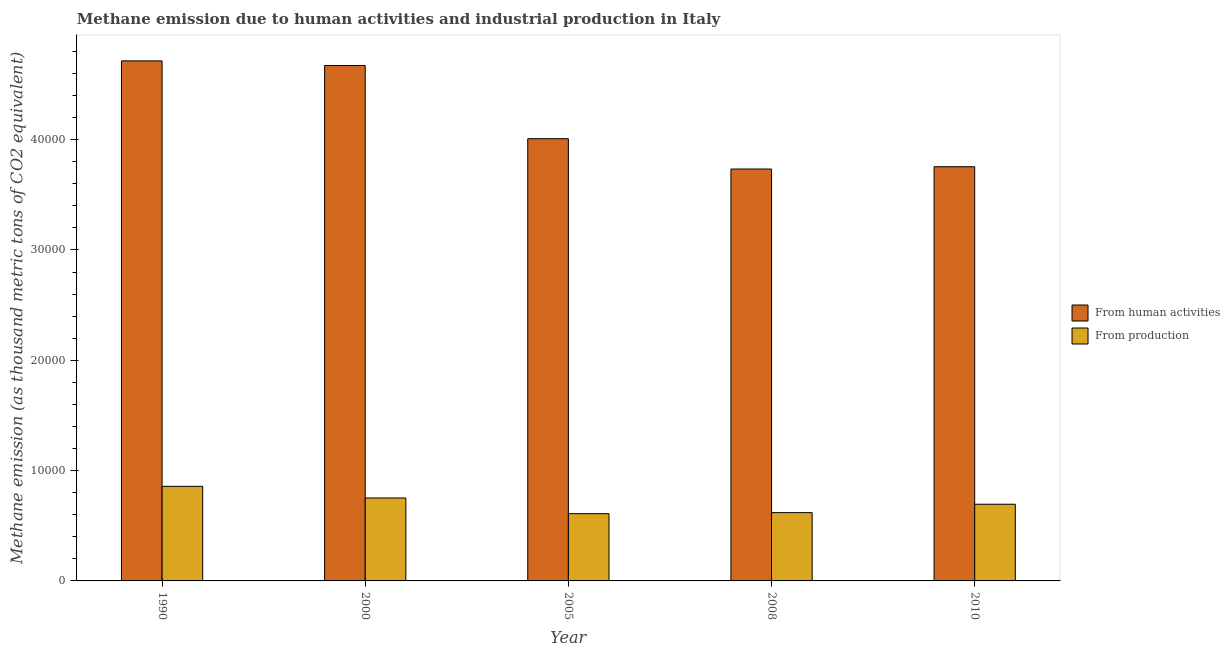How many groups of bars are there?
Your response must be concise. 5. Are the number of bars per tick equal to the number of legend labels?
Provide a short and direct response. Yes. How many bars are there on the 1st tick from the left?
Provide a short and direct response. 2. In how many cases, is the number of bars for a given year not equal to the number of legend labels?
Your response must be concise. 0. What is the amount of emissions from human activities in 2005?
Your response must be concise. 4.01e+04. Across all years, what is the maximum amount of emissions generated from industries?
Offer a very short reply. 8574.9. Across all years, what is the minimum amount of emissions from human activities?
Your answer should be compact. 3.73e+04. In which year was the amount of emissions from human activities maximum?
Provide a succinct answer. 1990. In which year was the amount of emissions from human activities minimum?
Ensure brevity in your answer.  2008. What is the total amount of emissions generated from industries in the graph?
Keep it short and to the point. 3.53e+04. What is the difference between the amount of emissions from human activities in 1990 and that in 2010?
Give a very brief answer. 9595.9. What is the difference between the amount of emissions generated from industries in 1990 and the amount of emissions from human activities in 2010?
Provide a short and direct response. 1623.4. What is the average amount of emissions generated from industries per year?
Make the answer very short. 7066.6. In the year 1990, what is the difference between the amount of emissions from human activities and amount of emissions generated from industries?
Your answer should be compact. 0. In how many years, is the amount of emissions generated from industries greater than 16000 thousand metric tons?
Ensure brevity in your answer.  0. What is the ratio of the amount of emissions from human activities in 1990 to that in 2008?
Keep it short and to the point. 1.26. What is the difference between the highest and the second highest amount of emissions generated from industries?
Offer a terse response. 1055.7. What is the difference between the highest and the lowest amount of emissions generated from industries?
Your answer should be compact. 2478. In how many years, is the amount of emissions generated from industries greater than the average amount of emissions generated from industries taken over all years?
Offer a very short reply. 2. What does the 2nd bar from the left in 2008 represents?
Give a very brief answer. From production. What does the 1st bar from the right in 2008 represents?
Keep it short and to the point. From production. What is the difference between two consecutive major ticks on the Y-axis?
Your answer should be very brief. 10000. Are the values on the major ticks of Y-axis written in scientific E-notation?
Your answer should be compact. No. Does the graph contain any zero values?
Your response must be concise. No. Does the graph contain grids?
Your answer should be compact. No. How are the legend labels stacked?
Keep it short and to the point. Vertical. What is the title of the graph?
Provide a short and direct response. Methane emission due to human activities and industrial production in Italy. What is the label or title of the X-axis?
Your response must be concise. Year. What is the label or title of the Y-axis?
Offer a terse response. Methane emission (as thousand metric tons of CO2 equivalent). What is the Methane emission (as thousand metric tons of CO2 equivalent) in From human activities in 1990?
Your answer should be compact. 4.71e+04. What is the Methane emission (as thousand metric tons of CO2 equivalent) in From production in 1990?
Your answer should be compact. 8574.9. What is the Methane emission (as thousand metric tons of CO2 equivalent) in From human activities in 2000?
Your response must be concise. 4.67e+04. What is the Methane emission (as thousand metric tons of CO2 equivalent) of From production in 2000?
Your answer should be compact. 7519.2. What is the Methane emission (as thousand metric tons of CO2 equivalent) in From human activities in 2005?
Offer a terse response. 4.01e+04. What is the Methane emission (as thousand metric tons of CO2 equivalent) of From production in 2005?
Your answer should be compact. 6096.9. What is the Methane emission (as thousand metric tons of CO2 equivalent) of From human activities in 2008?
Offer a terse response. 3.73e+04. What is the Methane emission (as thousand metric tons of CO2 equivalent) of From production in 2008?
Keep it short and to the point. 6190.5. What is the Methane emission (as thousand metric tons of CO2 equivalent) of From human activities in 2010?
Offer a terse response. 3.75e+04. What is the Methane emission (as thousand metric tons of CO2 equivalent) in From production in 2010?
Your answer should be compact. 6951.5. Across all years, what is the maximum Methane emission (as thousand metric tons of CO2 equivalent) in From human activities?
Keep it short and to the point. 4.71e+04. Across all years, what is the maximum Methane emission (as thousand metric tons of CO2 equivalent) in From production?
Make the answer very short. 8574.9. Across all years, what is the minimum Methane emission (as thousand metric tons of CO2 equivalent) in From human activities?
Keep it short and to the point. 3.73e+04. Across all years, what is the minimum Methane emission (as thousand metric tons of CO2 equivalent) in From production?
Keep it short and to the point. 6096.9. What is the total Methane emission (as thousand metric tons of CO2 equivalent) in From human activities in the graph?
Provide a short and direct response. 2.09e+05. What is the total Methane emission (as thousand metric tons of CO2 equivalent) in From production in the graph?
Give a very brief answer. 3.53e+04. What is the difference between the Methane emission (as thousand metric tons of CO2 equivalent) in From human activities in 1990 and that in 2000?
Your answer should be very brief. 418.9. What is the difference between the Methane emission (as thousand metric tons of CO2 equivalent) of From production in 1990 and that in 2000?
Ensure brevity in your answer.  1055.7. What is the difference between the Methane emission (as thousand metric tons of CO2 equivalent) in From human activities in 1990 and that in 2005?
Offer a terse response. 7054.5. What is the difference between the Methane emission (as thousand metric tons of CO2 equivalent) of From production in 1990 and that in 2005?
Offer a very short reply. 2478. What is the difference between the Methane emission (as thousand metric tons of CO2 equivalent) in From human activities in 1990 and that in 2008?
Keep it short and to the point. 9804.1. What is the difference between the Methane emission (as thousand metric tons of CO2 equivalent) in From production in 1990 and that in 2008?
Your response must be concise. 2384.4. What is the difference between the Methane emission (as thousand metric tons of CO2 equivalent) in From human activities in 1990 and that in 2010?
Your response must be concise. 9595.9. What is the difference between the Methane emission (as thousand metric tons of CO2 equivalent) of From production in 1990 and that in 2010?
Make the answer very short. 1623.4. What is the difference between the Methane emission (as thousand metric tons of CO2 equivalent) in From human activities in 2000 and that in 2005?
Your answer should be very brief. 6635.6. What is the difference between the Methane emission (as thousand metric tons of CO2 equivalent) in From production in 2000 and that in 2005?
Provide a short and direct response. 1422.3. What is the difference between the Methane emission (as thousand metric tons of CO2 equivalent) in From human activities in 2000 and that in 2008?
Your response must be concise. 9385.2. What is the difference between the Methane emission (as thousand metric tons of CO2 equivalent) of From production in 2000 and that in 2008?
Give a very brief answer. 1328.7. What is the difference between the Methane emission (as thousand metric tons of CO2 equivalent) in From human activities in 2000 and that in 2010?
Keep it short and to the point. 9177. What is the difference between the Methane emission (as thousand metric tons of CO2 equivalent) of From production in 2000 and that in 2010?
Your answer should be compact. 567.7. What is the difference between the Methane emission (as thousand metric tons of CO2 equivalent) of From human activities in 2005 and that in 2008?
Your answer should be very brief. 2749.6. What is the difference between the Methane emission (as thousand metric tons of CO2 equivalent) in From production in 2005 and that in 2008?
Offer a very short reply. -93.6. What is the difference between the Methane emission (as thousand metric tons of CO2 equivalent) in From human activities in 2005 and that in 2010?
Your answer should be compact. 2541.4. What is the difference between the Methane emission (as thousand metric tons of CO2 equivalent) in From production in 2005 and that in 2010?
Provide a short and direct response. -854.6. What is the difference between the Methane emission (as thousand metric tons of CO2 equivalent) in From human activities in 2008 and that in 2010?
Your response must be concise. -208.2. What is the difference between the Methane emission (as thousand metric tons of CO2 equivalent) of From production in 2008 and that in 2010?
Offer a very short reply. -761. What is the difference between the Methane emission (as thousand metric tons of CO2 equivalent) in From human activities in 1990 and the Methane emission (as thousand metric tons of CO2 equivalent) in From production in 2000?
Your response must be concise. 3.96e+04. What is the difference between the Methane emission (as thousand metric tons of CO2 equivalent) of From human activities in 1990 and the Methane emission (as thousand metric tons of CO2 equivalent) of From production in 2005?
Your answer should be very brief. 4.10e+04. What is the difference between the Methane emission (as thousand metric tons of CO2 equivalent) in From human activities in 1990 and the Methane emission (as thousand metric tons of CO2 equivalent) in From production in 2008?
Your answer should be compact. 4.10e+04. What is the difference between the Methane emission (as thousand metric tons of CO2 equivalent) in From human activities in 1990 and the Methane emission (as thousand metric tons of CO2 equivalent) in From production in 2010?
Offer a very short reply. 4.02e+04. What is the difference between the Methane emission (as thousand metric tons of CO2 equivalent) in From human activities in 2000 and the Methane emission (as thousand metric tons of CO2 equivalent) in From production in 2005?
Your response must be concise. 4.06e+04. What is the difference between the Methane emission (as thousand metric tons of CO2 equivalent) of From human activities in 2000 and the Methane emission (as thousand metric tons of CO2 equivalent) of From production in 2008?
Offer a terse response. 4.05e+04. What is the difference between the Methane emission (as thousand metric tons of CO2 equivalent) of From human activities in 2000 and the Methane emission (as thousand metric tons of CO2 equivalent) of From production in 2010?
Give a very brief answer. 3.98e+04. What is the difference between the Methane emission (as thousand metric tons of CO2 equivalent) of From human activities in 2005 and the Methane emission (as thousand metric tons of CO2 equivalent) of From production in 2008?
Your answer should be compact. 3.39e+04. What is the difference between the Methane emission (as thousand metric tons of CO2 equivalent) in From human activities in 2005 and the Methane emission (as thousand metric tons of CO2 equivalent) in From production in 2010?
Offer a terse response. 3.31e+04. What is the difference between the Methane emission (as thousand metric tons of CO2 equivalent) in From human activities in 2008 and the Methane emission (as thousand metric tons of CO2 equivalent) in From production in 2010?
Give a very brief answer. 3.04e+04. What is the average Methane emission (as thousand metric tons of CO2 equivalent) of From human activities per year?
Offer a terse response. 4.18e+04. What is the average Methane emission (as thousand metric tons of CO2 equivalent) in From production per year?
Make the answer very short. 7066.6. In the year 1990, what is the difference between the Methane emission (as thousand metric tons of CO2 equivalent) in From human activities and Methane emission (as thousand metric tons of CO2 equivalent) in From production?
Give a very brief answer. 3.86e+04. In the year 2000, what is the difference between the Methane emission (as thousand metric tons of CO2 equivalent) of From human activities and Methane emission (as thousand metric tons of CO2 equivalent) of From production?
Keep it short and to the point. 3.92e+04. In the year 2005, what is the difference between the Methane emission (as thousand metric tons of CO2 equivalent) in From human activities and Methane emission (as thousand metric tons of CO2 equivalent) in From production?
Offer a terse response. 3.40e+04. In the year 2008, what is the difference between the Methane emission (as thousand metric tons of CO2 equivalent) of From human activities and Methane emission (as thousand metric tons of CO2 equivalent) of From production?
Provide a succinct answer. 3.11e+04. In the year 2010, what is the difference between the Methane emission (as thousand metric tons of CO2 equivalent) in From human activities and Methane emission (as thousand metric tons of CO2 equivalent) in From production?
Your response must be concise. 3.06e+04. What is the ratio of the Methane emission (as thousand metric tons of CO2 equivalent) in From human activities in 1990 to that in 2000?
Provide a succinct answer. 1.01. What is the ratio of the Methane emission (as thousand metric tons of CO2 equivalent) of From production in 1990 to that in 2000?
Your response must be concise. 1.14. What is the ratio of the Methane emission (as thousand metric tons of CO2 equivalent) in From human activities in 1990 to that in 2005?
Offer a very short reply. 1.18. What is the ratio of the Methane emission (as thousand metric tons of CO2 equivalent) of From production in 1990 to that in 2005?
Offer a terse response. 1.41. What is the ratio of the Methane emission (as thousand metric tons of CO2 equivalent) in From human activities in 1990 to that in 2008?
Your answer should be very brief. 1.26. What is the ratio of the Methane emission (as thousand metric tons of CO2 equivalent) of From production in 1990 to that in 2008?
Make the answer very short. 1.39. What is the ratio of the Methane emission (as thousand metric tons of CO2 equivalent) of From human activities in 1990 to that in 2010?
Offer a very short reply. 1.26. What is the ratio of the Methane emission (as thousand metric tons of CO2 equivalent) of From production in 1990 to that in 2010?
Give a very brief answer. 1.23. What is the ratio of the Methane emission (as thousand metric tons of CO2 equivalent) of From human activities in 2000 to that in 2005?
Provide a short and direct response. 1.17. What is the ratio of the Methane emission (as thousand metric tons of CO2 equivalent) of From production in 2000 to that in 2005?
Provide a succinct answer. 1.23. What is the ratio of the Methane emission (as thousand metric tons of CO2 equivalent) in From human activities in 2000 to that in 2008?
Make the answer very short. 1.25. What is the ratio of the Methane emission (as thousand metric tons of CO2 equivalent) of From production in 2000 to that in 2008?
Ensure brevity in your answer.  1.21. What is the ratio of the Methane emission (as thousand metric tons of CO2 equivalent) of From human activities in 2000 to that in 2010?
Give a very brief answer. 1.24. What is the ratio of the Methane emission (as thousand metric tons of CO2 equivalent) of From production in 2000 to that in 2010?
Keep it short and to the point. 1.08. What is the ratio of the Methane emission (as thousand metric tons of CO2 equivalent) of From human activities in 2005 to that in 2008?
Your answer should be compact. 1.07. What is the ratio of the Methane emission (as thousand metric tons of CO2 equivalent) in From production in 2005 to that in 2008?
Provide a succinct answer. 0.98. What is the ratio of the Methane emission (as thousand metric tons of CO2 equivalent) in From human activities in 2005 to that in 2010?
Ensure brevity in your answer.  1.07. What is the ratio of the Methane emission (as thousand metric tons of CO2 equivalent) of From production in 2005 to that in 2010?
Ensure brevity in your answer.  0.88. What is the ratio of the Methane emission (as thousand metric tons of CO2 equivalent) in From human activities in 2008 to that in 2010?
Make the answer very short. 0.99. What is the ratio of the Methane emission (as thousand metric tons of CO2 equivalent) in From production in 2008 to that in 2010?
Provide a short and direct response. 0.89. What is the difference between the highest and the second highest Methane emission (as thousand metric tons of CO2 equivalent) of From human activities?
Make the answer very short. 418.9. What is the difference between the highest and the second highest Methane emission (as thousand metric tons of CO2 equivalent) in From production?
Keep it short and to the point. 1055.7. What is the difference between the highest and the lowest Methane emission (as thousand metric tons of CO2 equivalent) in From human activities?
Provide a succinct answer. 9804.1. What is the difference between the highest and the lowest Methane emission (as thousand metric tons of CO2 equivalent) of From production?
Offer a very short reply. 2478. 